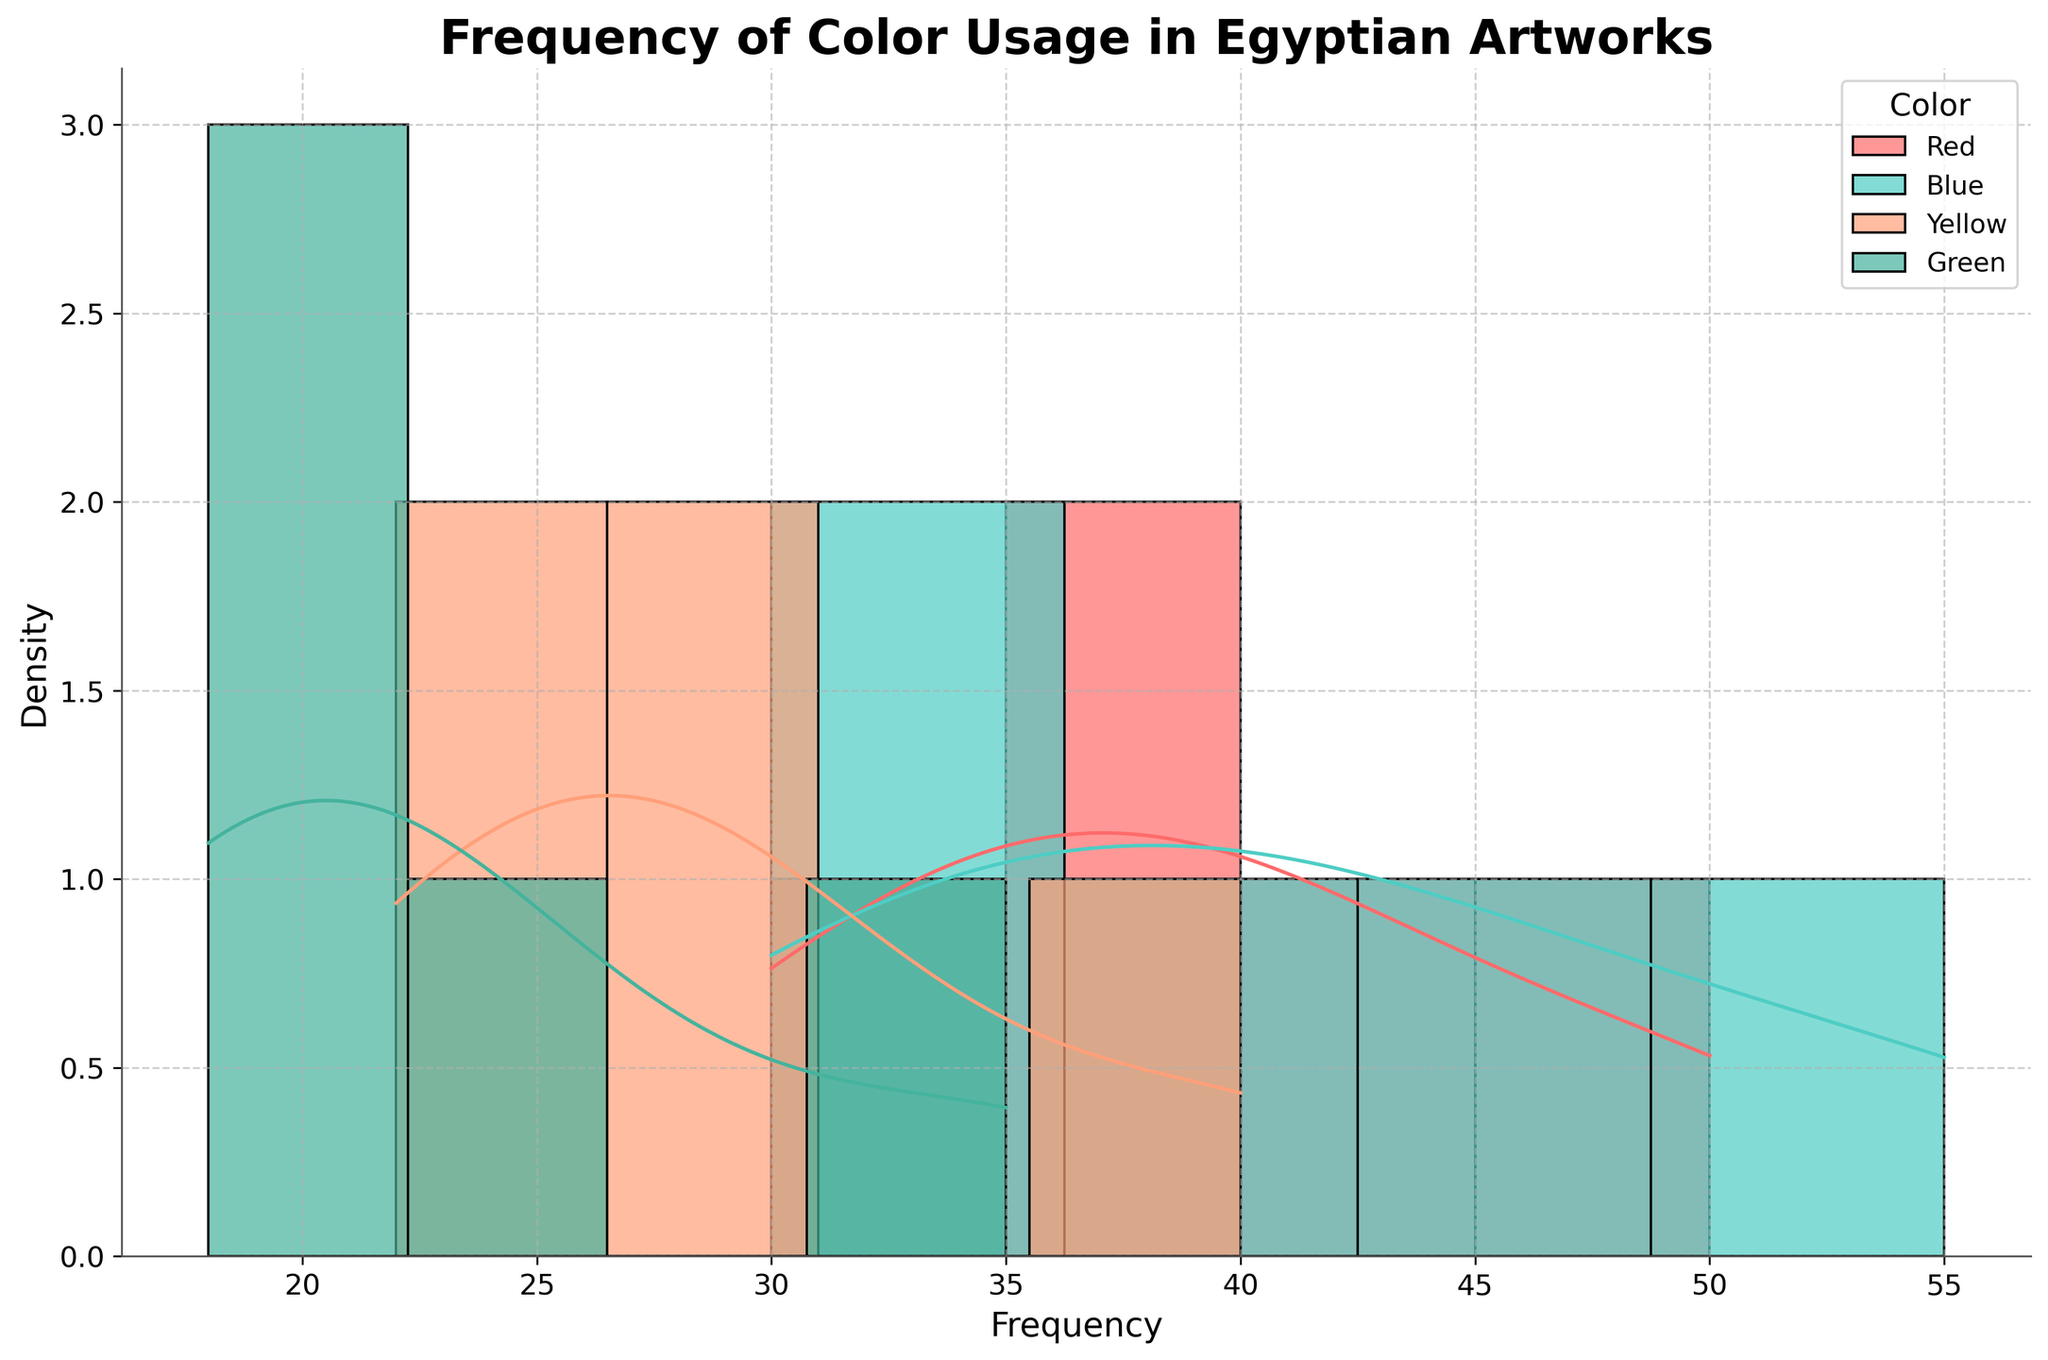What's the title of the figure? The title is located at the top of the figure and provides an overview of the data being presented. It reads "Frequency of Color Usage in Egyptian Artworks".
Answer: Frequency of Color Usage in Egyptian Artworks What does the x-axis represent in the figure? The x-axis typically represents the variable being measured or analyzed. In this figure, it shows the "Frequency," which indicates how often each color was used in Egyptian artworks.
Answer: Frequency How many colors are represented in the histogram with KDE? By examining the different color bars and labels, one can count the unique colors being analyzed. There are four distinct colors.
Answer: Four Which dynasty shows the highest frequency for blue? To find this, look at the peaks of the blue histograms and their corresponding KDE curves and compare the maximum frequencies. It's evident that the New Kingdom has the highest peak for blue.
Answer: New Kingdom Which color has the lowest frequency range across all dynasties? Analyze the histograms and KDE curves for each color and identify the one that consistently has the smallest range across the x-axis. Green shows the lowest frequency range across the dynasties.
Answer: Green Compare the average frequency of red and blue colors in the New Kingdom. Which is higher? To determine the average, one can look at the density of the KDE curve. For the New Kingdom, the blue color's KDE peak and density appear higher and more frequent than that of red. Therefore, blue has a higher average frequency.
Answer: Blue How does the frequency of green color change from the Old Kingdom to the New Kingdom? Compare the height and position of the green histograms and KDE curves for the Old Kingdom versus the New Kingdom. The green color frequency increases from the Old Kingdom to the New Kingdom.
Answer: Increases What is the most frequently used color in the Middle Kingdom? Identify the histograms in the Middle Kingdom and compare the heights of the bars for each color. Blue shows the highest histogram bars in the Middle Kingdom.
Answer: Blue What's the range of frequency values for yellow across all dynasties? Determine the minimum and maximum frequency values represented by yellow in the histograms. The range is calculated as the difference between max and min values (40 - 22 = 18).
Answer: 18 Is there a color that consistently decreases in frequency over different dynasties? Inspect the histograms and KDE curves of each color across the dynasties and check for a decreasing trend. Red shows a consistent decrease, especially notable from the New Kingdom to the Roman period.
Answer: Red 